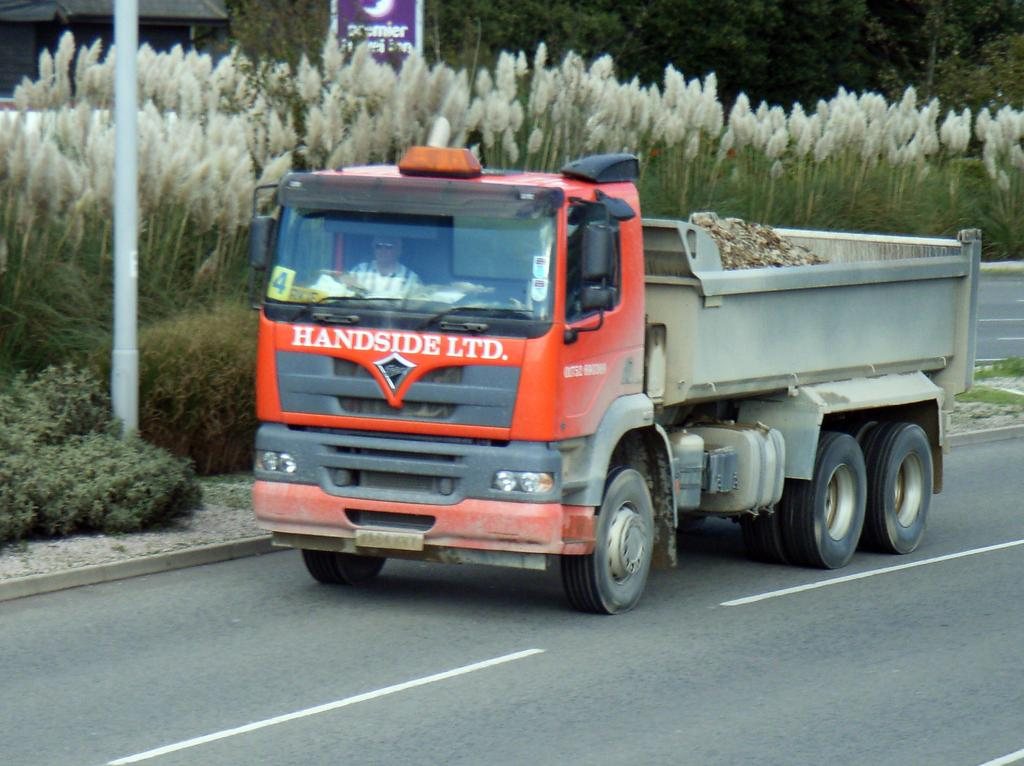What is the main subject of the image? The main subject of the image is a truck. Can you describe the person inside the truck? A person is inside the truck, but their appearance or actions are not specified. What can be seen in the background of the image? There is a road visible in the image, as well as a pole on the left side with plants near it, and trees. What type of voyage is the farmer embarking on in the image? There is no farmer present in the image, and no voyage is mentioned or depicted. 